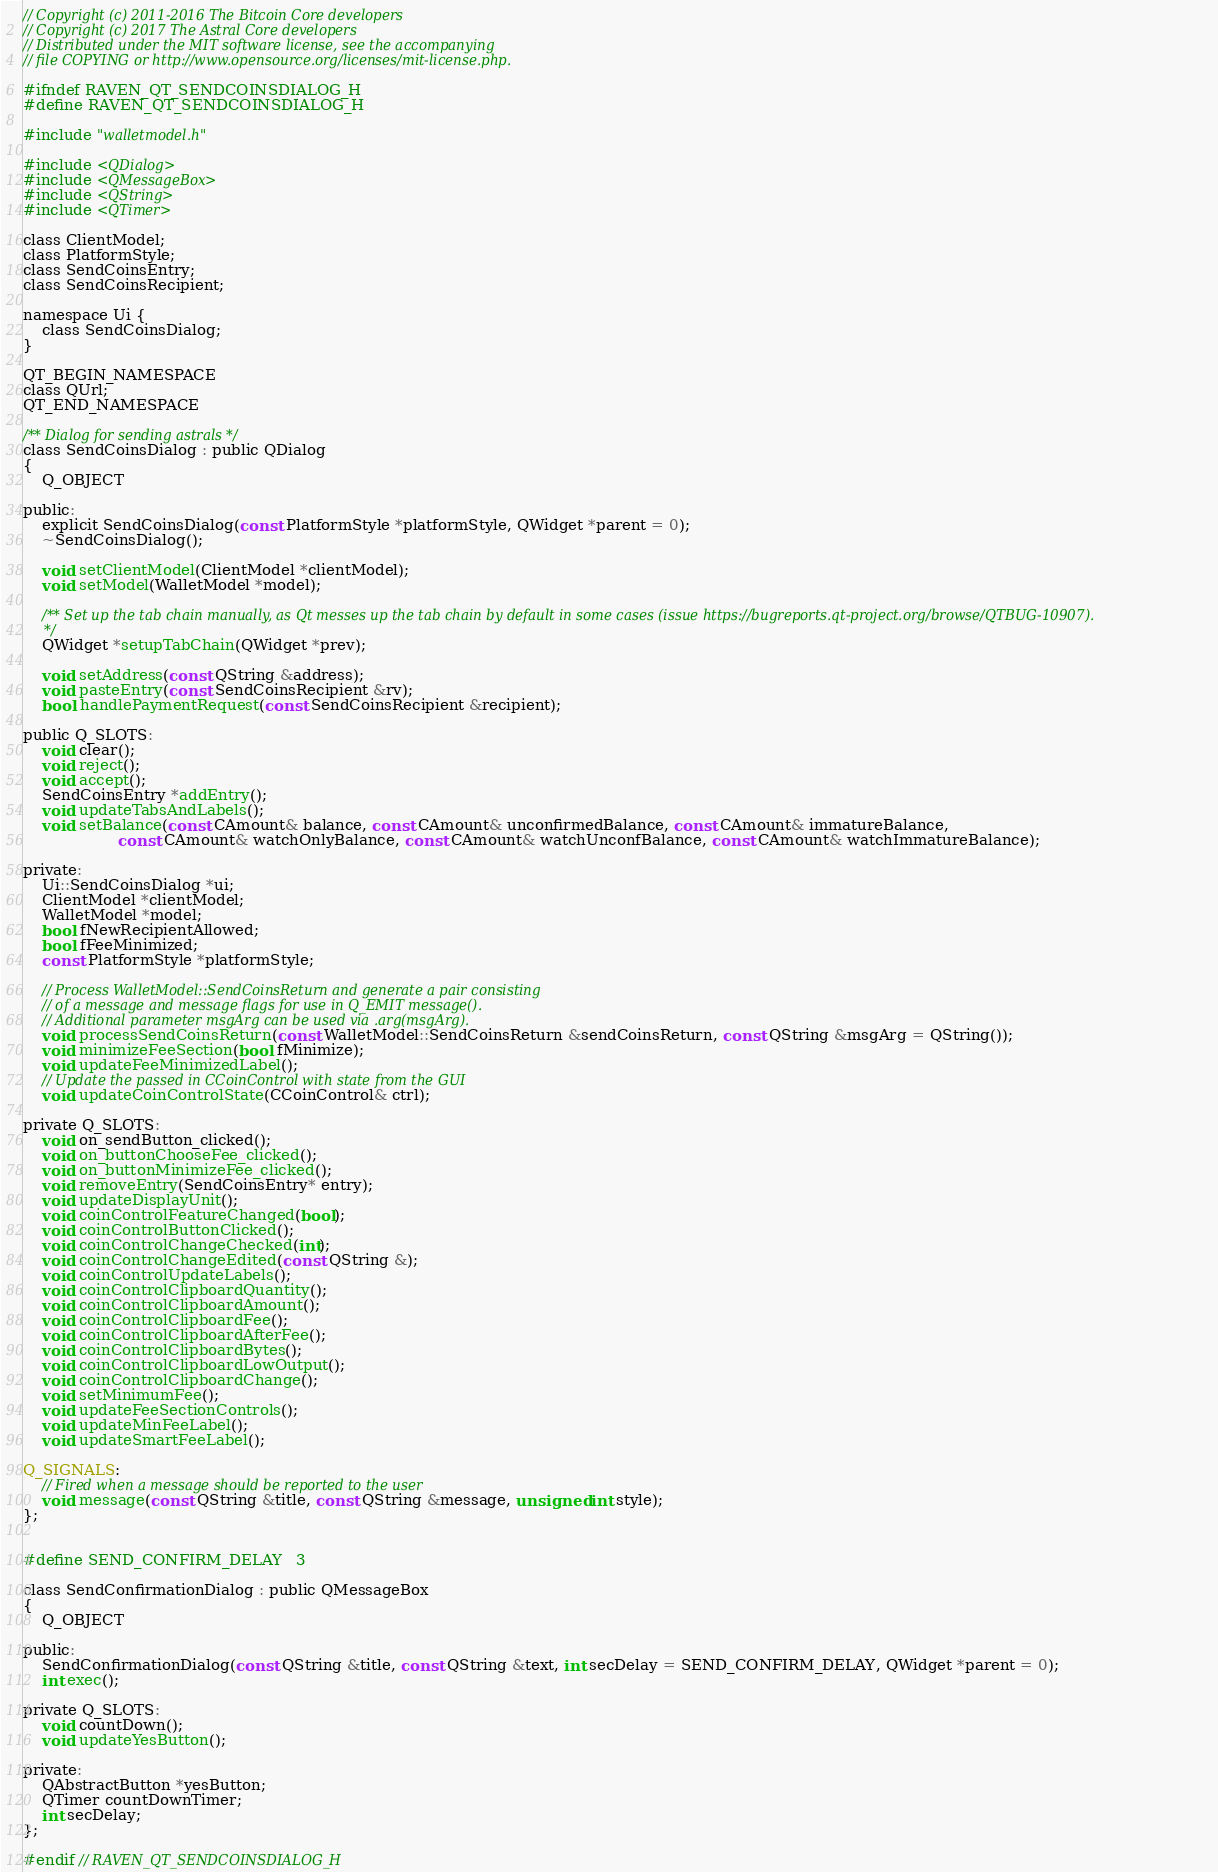<code> <loc_0><loc_0><loc_500><loc_500><_C_>// Copyright (c) 2011-2016 The Bitcoin Core developers
// Copyright (c) 2017 The Astral Core developers
// Distributed under the MIT software license, see the accompanying
// file COPYING or http://www.opensource.org/licenses/mit-license.php.

#ifndef RAVEN_QT_SENDCOINSDIALOG_H
#define RAVEN_QT_SENDCOINSDIALOG_H

#include "walletmodel.h"

#include <QDialog>
#include <QMessageBox>
#include <QString>
#include <QTimer>

class ClientModel;
class PlatformStyle;
class SendCoinsEntry;
class SendCoinsRecipient;

namespace Ui {
    class SendCoinsDialog;
}

QT_BEGIN_NAMESPACE
class QUrl;
QT_END_NAMESPACE

/** Dialog for sending astrals */
class SendCoinsDialog : public QDialog
{
    Q_OBJECT

public:
    explicit SendCoinsDialog(const PlatformStyle *platformStyle, QWidget *parent = 0);
    ~SendCoinsDialog();

    void setClientModel(ClientModel *clientModel);
    void setModel(WalletModel *model);

    /** Set up the tab chain manually, as Qt messes up the tab chain by default in some cases (issue https://bugreports.qt-project.org/browse/QTBUG-10907).
     */
    QWidget *setupTabChain(QWidget *prev);

    void setAddress(const QString &address);
    void pasteEntry(const SendCoinsRecipient &rv);
    bool handlePaymentRequest(const SendCoinsRecipient &recipient);

public Q_SLOTS:
    void clear();
    void reject();
    void accept();
    SendCoinsEntry *addEntry();
    void updateTabsAndLabels();
    void setBalance(const CAmount& balance, const CAmount& unconfirmedBalance, const CAmount& immatureBalance,
                    const CAmount& watchOnlyBalance, const CAmount& watchUnconfBalance, const CAmount& watchImmatureBalance);

private:
    Ui::SendCoinsDialog *ui;
    ClientModel *clientModel;
    WalletModel *model;
    bool fNewRecipientAllowed;
    bool fFeeMinimized;
    const PlatformStyle *platformStyle;

    // Process WalletModel::SendCoinsReturn and generate a pair consisting
    // of a message and message flags for use in Q_EMIT message().
    // Additional parameter msgArg can be used via .arg(msgArg).
    void processSendCoinsReturn(const WalletModel::SendCoinsReturn &sendCoinsReturn, const QString &msgArg = QString());
    void minimizeFeeSection(bool fMinimize);
    void updateFeeMinimizedLabel();
    // Update the passed in CCoinControl with state from the GUI
    void updateCoinControlState(CCoinControl& ctrl);

private Q_SLOTS:
    void on_sendButton_clicked();
    void on_buttonChooseFee_clicked();
    void on_buttonMinimizeFee_clicked();
    void removeEntry(SendCoinsEntry* entry);
    void updateDisplayUnit();
    void coinControlFeatureChanged(bool);
    void coinControlButtonClicked();
    void coinControlChangeChecked(int);
    void coinControlChangeEdited(const QString &);
    void coinControlUpdateLabels();
    void coinControlClipboardQuantity();
    void coinControlClipboardAmount();
    void coinControlClipboardFee();
    void coinControlClipboardAfterFee();
    void coinControlClipboardBytes();
    void coinControlClipboardLowOutput();
    void coinControlClipboardChange();
    void setMinimumFee();
    void updateFeeSectionControls();
    void updateMinFeeLabel();
    void updateSmartFeeLabel();

Q_SIGNALS:
    // Fired when a message should be reported to the user
    void message(const QString &title, const QString &message, unsigned int style);
};


#define SEND_CONFIRM_DELAY   3

class SendConfirmationDialog : public QMessageBox
{
    Q_OBJECT

public:
    SendConfirmationDialog(const QString &title, const QString &text, int secDelay = SEND_CONFIRM_DELAY, QWidget *parent = 0);
    int exec();

private Q_SLOTS:
    void countDown();
    void updateYesButton();

private:
    QAbstractButton *yesButton;
    QTimer countDownTimer;
    int secDelay;
};

#endif // RAVEN_QT_SENDCOINSDIALOG_H
</code> 